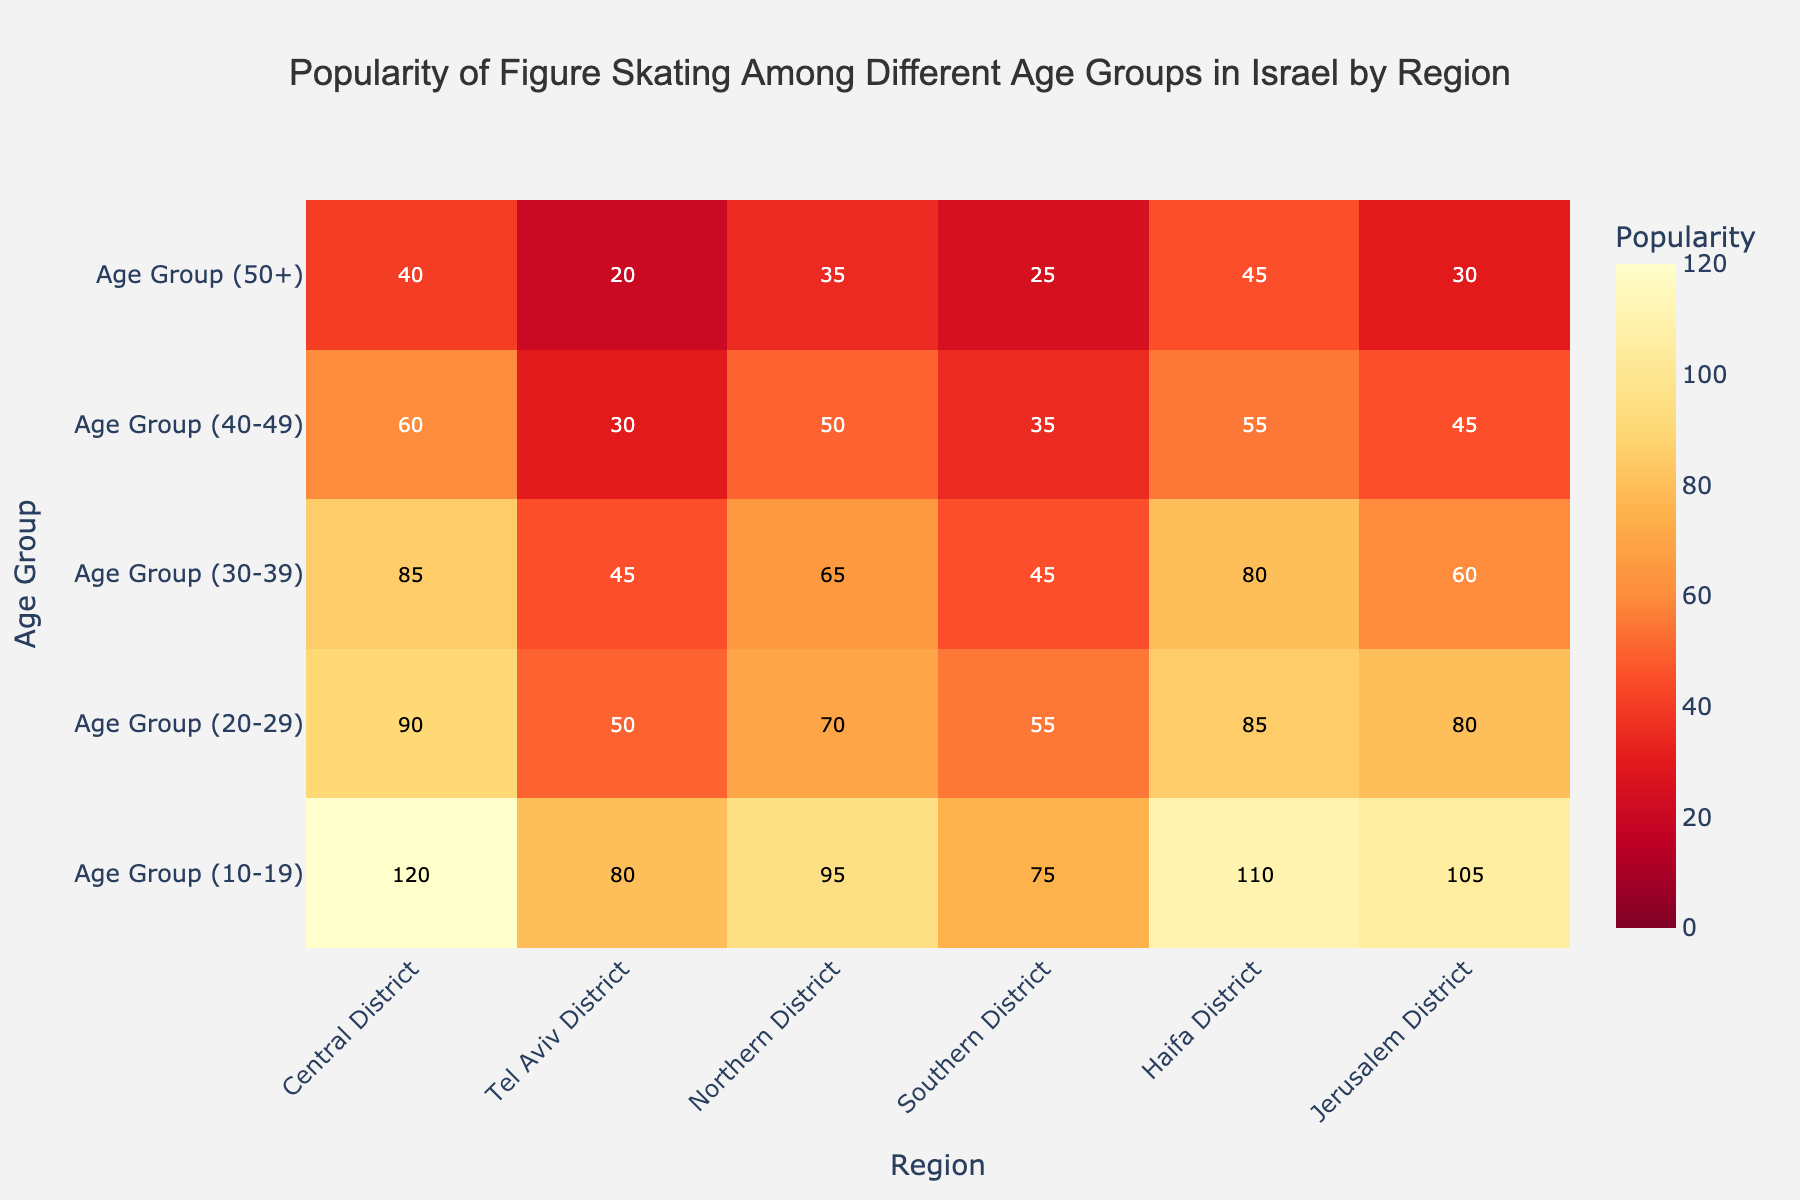Which region has the highest popularity of figure skating among the 10-19 age group? In the heatmap, the 10-19 age group values can be compared across all regions. The Central District shows the highest value for this age group.
Answer: Central District Which age group has the lowest popularity in the Tel Aviv District? In the heatmap, look at the Tel Aviv District values for each age group. The value is lowest for the 50+ age group.
Answer: 50+ How does the popularity of figure skating in the Southern District for the 20-29 age group compare to the Northern District for the same age group? Check the values for the 20-29 age group in both the Southern District and Northern District. The Southern District has a value of 55, while the Northern District has a value of 70, indicating higher popularity in the Northern District.
Answer: Northern District is higher What is the difference in popularity of figure skating between the 30-39 and 40-49 age groups in the Haifa District? Compare the values for the Haifa District in the 30-39 and 40-49 age groups. The values are 80 for 30-39 and 55 for 40-49. The difference is 80 - 55 = 25.
Answer: 25 Which age group exhibits the most significant drop in popularity from the Central District to the Tel Aviv District? Calculate the differences for each age group between the Central District and the Tel Aviv District. The drops are: 10-19 (40), 20-29 (40), 30-39 (40), 40-49 (30), 50+ (20). The most significant drop is in the 10-19, 20-29, and 30-39 age groups.
Answer: 10-19, 20-29, 30-39 What is the average popularity of figure skating for the 50+ age group across all regions? Sum the values for the 50+ age group in all regions and divide by the number of regions. The values are 40 (Central), 20 (Tel Aviv), 35 (Northern), 25 (Southern), 45 (Haifa), 30 (Jerusalem). The sum is 40 + 20 + 35 + 25 + 45 + 30 = 195, and the average is 195 / 6 ≈ 32.5.
Answer: 32.5 How does the popularity of figure skating in the 40-49 age group in the Jerusalem District compare to the average popularity in this age group across all regions? First, calculate the average for the 40-49 age group across all regions. The values are 60 (Central), 30 (Tel Aviv), 50 (Northern), 35 (Southern), 55 (Haifa), 45 (Jerusalem). Average is (60 + 30 + 50 + 35 + 55 + 45) / 6 ≈ 45. The Jerusalem District for 40-49 is 45, which is equal to the average.
Answer: Equal to the average Which region has the most uniform popularity distribution across all age groups, and how can you describe this uniformity? To find uniformity, look at the range of values (max - min) for each region. Calculate for all regions: Central (120-40=80), Tel Aviv (80-20=60), Northern (95-35=60), Southern (75-25=50), Haifa (110-45=65), Jerusalem (105-30=75). Southern District has the smallest range, indicating the most uniform distribution.
Answer: Southern District Is there any region where the popularity of figure skating constantly decreases with increasing age group? Examine each region to see if the values decrease from the youngest to the oldest age group. For Tel Aviv District, the values are 80, 50, 45, 30, 20, which all decrease as the age group increases.
Answer: Tel Aviv District 